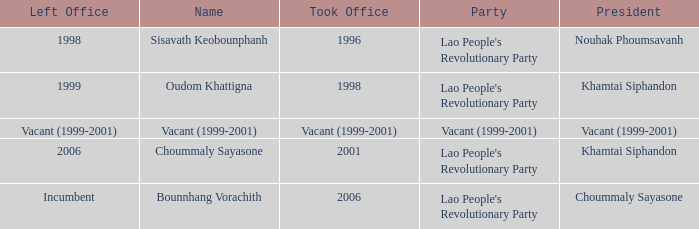What is Left Office, when Took Office is 2006? Incumbent. 